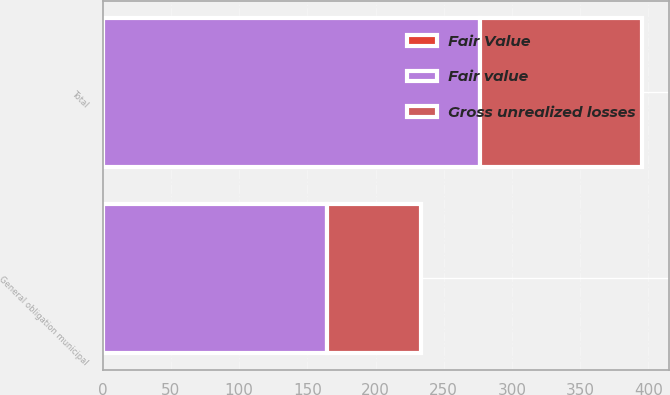Convert chart. <chart><loc_0><loc_0><loc_500><loc_500><stacked_bar_chart><ecel><fcel>General obligation municipal<fcel>Total<nl><fcel>Fair Value<fcel>0.1<fcel>0.1<nl><fcel>Gross unrealized losses<fcel>69.6<fcel>118.8<nl><fcel>Fair value<fcel>164<fcel>276.4<nl></chart> 